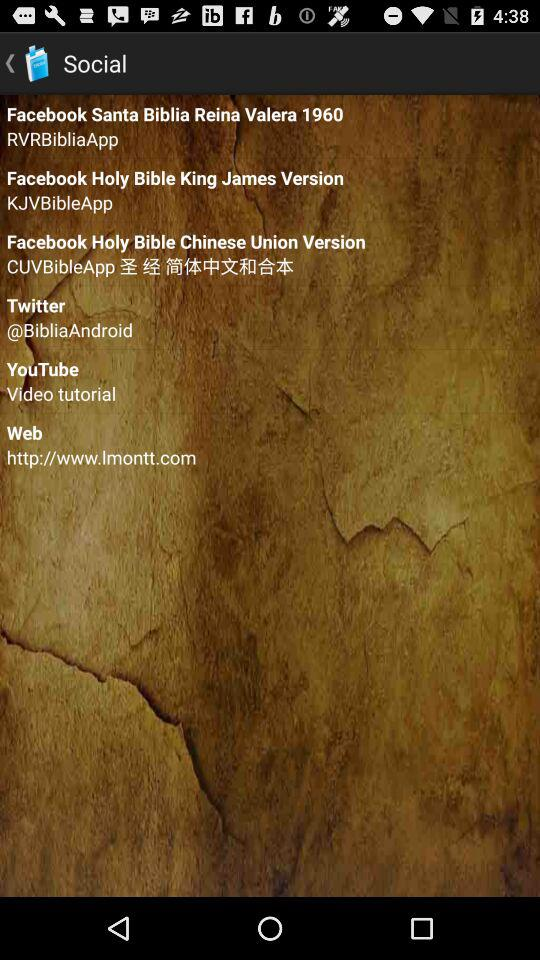What is Twitter handle name? The Twitter handle name is "@BibliaAndroid". 